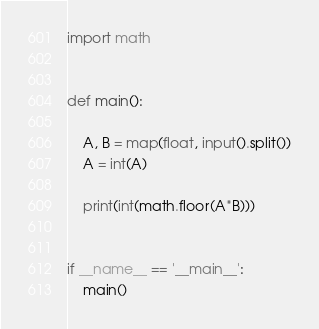<code> <loc_0><loc_0><loc_500><loc_500><_Python_>
import math


def main():

    A, B = map(float, input().split())
    A = int(A)

    print(int(math.floor(A*B)))


if __name__ == '__main__':
    main()
</code> 